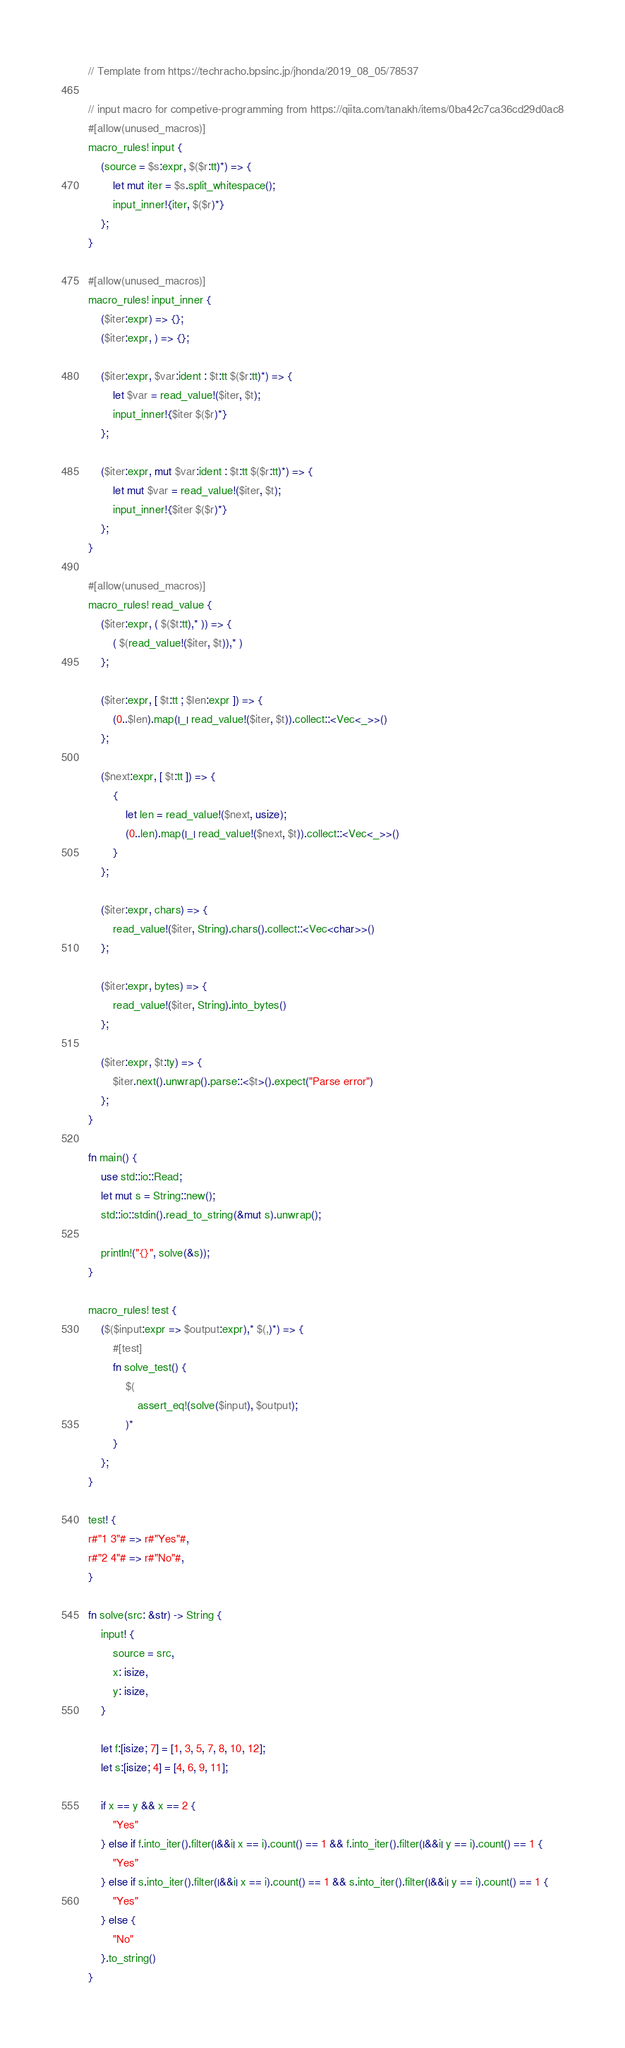Convert code to text. <code><loc_0><loc_0><loc_500><loc_500><_Rust_>// Template from https://techracho.bpsinc.jp/jhonda/2019_08_05/78537

// input macro for competive-programming from https://qiita.com/tanakh/items/0ba42c7ca36cd29d0ac8
#[allow(unused_macros)]
macro_rules! input {
    (source = $s:expr, $($r:tt)*) => {
        let mut iter = $s.split_whitespace();
        input_inner!{iter, $($r)*}
    };
}

#[allow(unused_macros)]
macro_rules! input_inner {
    ($iter:expr) => {};
    ($iter:expr, ) => {};

    ($iter:expr, $var:ident : $t:tt $($r:tt)*) => {
        let $var = read_value!($iter, $t);
        input_inner!{$iter $($r)*}
    };

    ($iter:expr, mut $var:ident : $t:tt $($r:tt)*) => {
        let mut $var = read_value!($iter, $t);
        input_inner!{$iter $($r)*}
    };
}

#[allow(unused_macros)]
macro_rules! read_value {
    ($iter:expr, ( $($t:tt),* )) => {
        ( $(read_value!($iter, $t)),* )
    };

    ($iter:expr, [ $t:tt ; $len:expr ]) => {
        (0..$len).map(|_| read_value!($iter, $t)).collect::<Vec<_>>()
    };

    ($next:expr, [ $t:tt ]) => {
        {
            let len = read_value!($next, usize);
            (0..len).map(|_| read_value!($next, $t)).collect::<Vec<_>>()
        }
    };

    ($iter:expr, chars) => {
        read_value!($iter, String).chars().collect::<Vec<char>>()
    };

    ($iter:expr, bytes) => {
        read_value!($iter, String).into_bytes()
    };

    ($iter:expr, $t:ty) => {
        $iter.next().unwrap().parse::<$t>().expect("Parse error")
    };
}

fn main() {
    use std::io::Read;
    let mut s = String::new();
    std::io::stdin().read_to_string(&mut s).unwrap();

    println!("{}", solve(&s));
}

macro_rules! test {
    ($($input:expr => $output:expr),* $(,)*) => {
        #[test]
        fn solve_test() {
            $(
                assert_eq!(solve($input), $output);
            )*
        }
    };
}

test! {
r#"1 3"# => r#"Yes"#,
r#"2 4"# => r#"No"#,
}

fn solve(src: &str) -> String {
    input! {
        source = src,
        x: isize,
        y: isize,
    }

    let f:[isize; 7] = [1, 3, 5, 7, 8, 10, 12];
    let s:[isize; 4] = [4, 6, 9, 11];

    if x == y && x == 2 {
        "Yes"
    } else if f.into_iter().filter(|&&i| x == i).count() == 1 && f.into_iter().filter(|&&i| y == i).count() == 1 {
        "Yes"
    } else if s.into_iter().filter(|&&i| x == i).count() == 1 && s.into_iter().filter(|&&i| y == i).count() == 1 {
        "Yes"
    } else {
        "No"
    }.to_string()
}</code> 